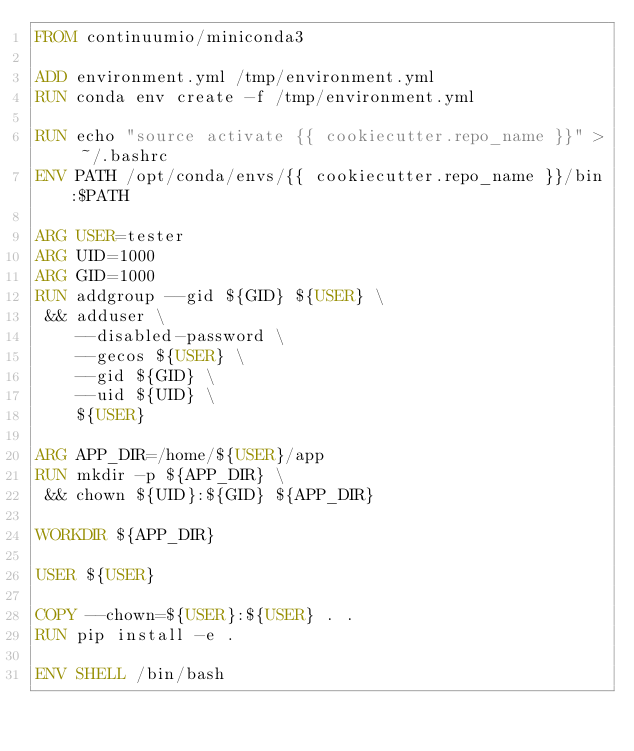<code> <loc_0><loc_0><loc_500><loc_500><_Dockerfile_>FROM continuumio/miniconda3

ADD environment.yml /tmp/environment.yml
RUN conda env create -f /tmp/environment.yml

RUN echo "source activate {{ cookiecutter.repo_name }}" > ~/.bashrc
ENV PATH /opt/conda/envs/{{ cookiecutter.repo_name }}/bin:$PATH

ARG USER=tester
ARG UID=1000
ARG GID=1000
RUN addgroup --gid ${GID} ${USER} \
 && adduser \
    --disabled-password \
    --gecos ${USER} \
    --gid ${GID} \
    --uid ${UID} \
    ${USER}

ARG APP_DIR=/home/${USER}/app
RUN mkdir -p ${APP_DIR} \
 && chown ${UID}:${GID} ${APP_DIR}

WORKDIR ${APP_DIR}

USER ${USER}

COPY --chown=${USER}:${USER} . .
RUN pip install -e .

ENV SHELL /bin/bash</code> 